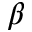Convert formula to latex. <formula><loc_0><loc_0><loc_500><loc_500>\beta</formula> 